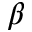Convert formula to latex. <formula><loc_0><loc_0><loc_500><loc_500>\beta</formula> 